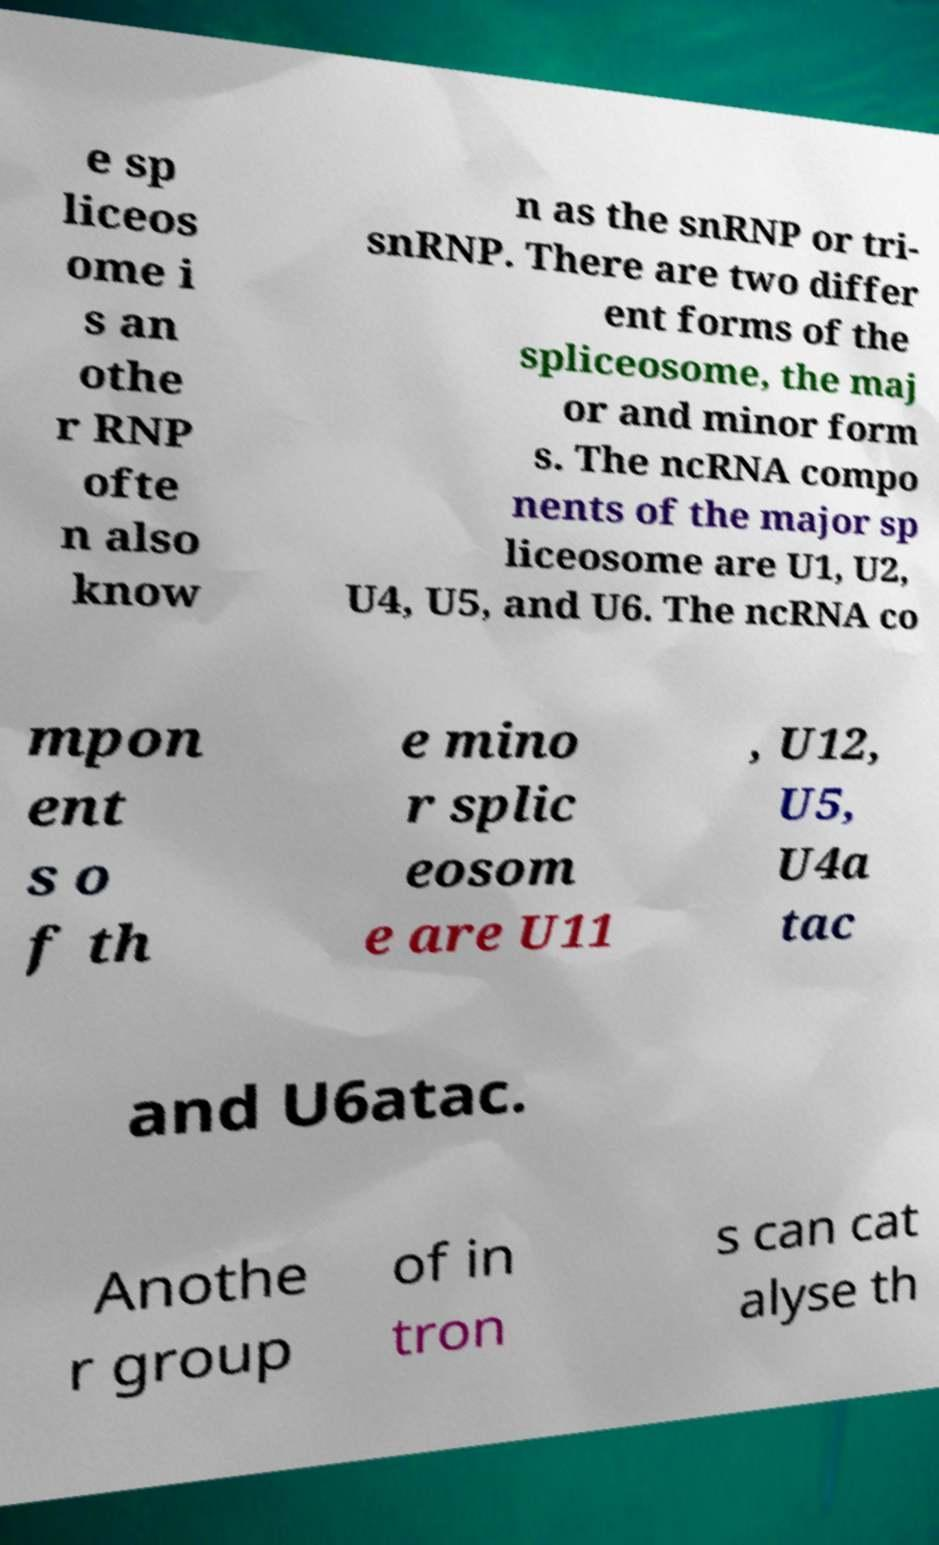Please identify and transcribe the text found in this image. e sp liceos ome i s an othe r RNP ofte n also know n as the snRNP or tri- snRNP. There are two differ ent forms of the spliceosome, the maj or and minor form s. The ncRNA compo nents of the major sp liceosome are U1, U2, U4, U5, and U6. The ncRNA co mpon ent s o f th e mino r splic eosom e are U11 , U12, U5, U4a tac and U6atac. Anothe r group of in tron s can cat alyse th 